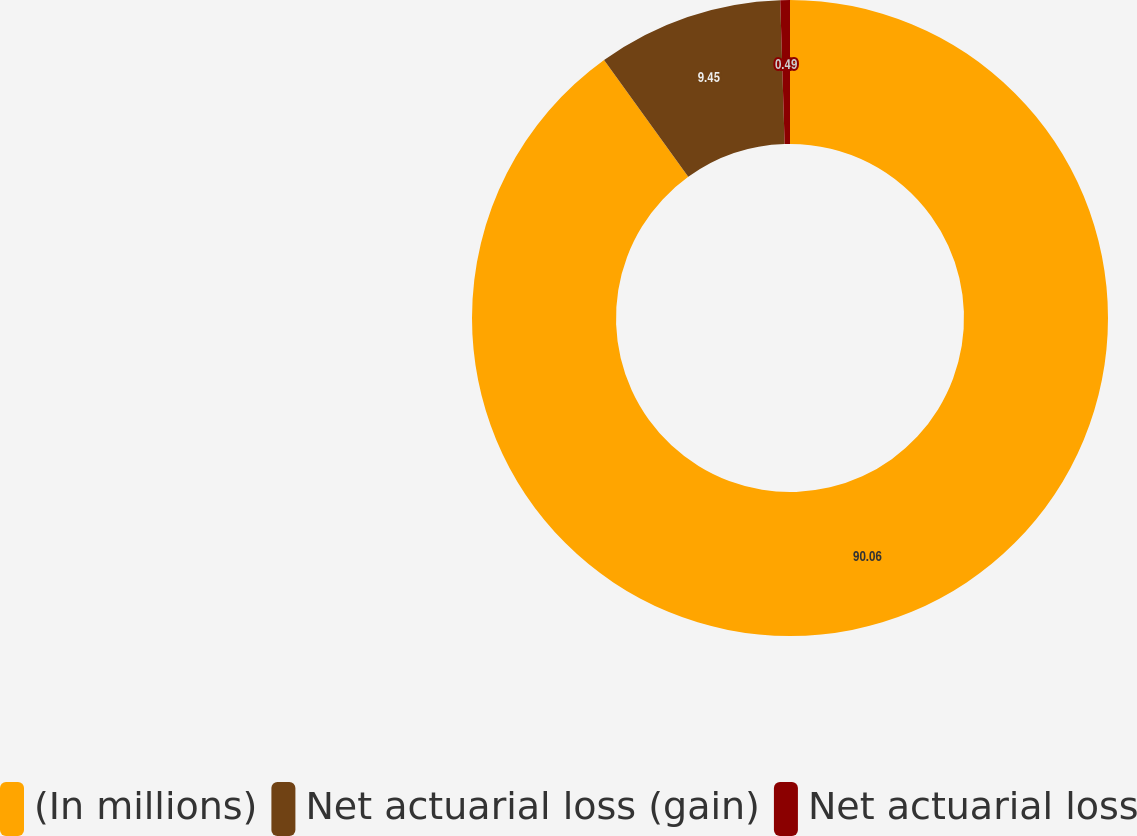Convert chart to OTSL. <chart><loc_0><loc_0><loc_500><loc_500><pie_chart><fcel>(In millions)<fcel>Net actuarial loss (gain)<fcel>Net actuarial loss<nl><fcel>90.06%<fcel>9.45%<fcel>0.49%<nl></chart> 